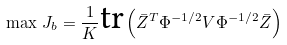<formula> <loc_0><loc_0><loc_500><loc_500>\max \, J _ { b } = \frac { 1 } { K } \text {tr} \left ( \bar { Z } ^ { T } \Phi ^ { - 1 / 2 } V \Phi ^ { - 1 / 2 } \bar { Z } \right )</formula> 